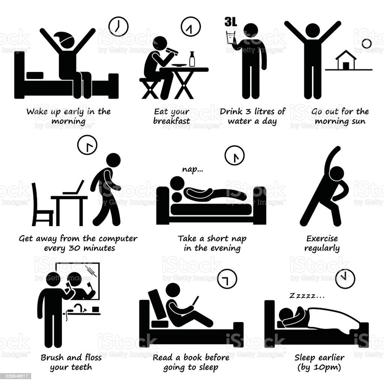What are some of the healthy habits mentioned in the image? The image effectively outlines several healthy habits critical for everyday wellness: rising early, enjoying a balanced breakfast, drinking at least 3 liters of water daily, absorbing morning sunlight, taking regular breaks from screen activity every 30 minutes, embracing brief afternoon naps, engaging in daily physical activity, maintaining oral hygiene by brushing and flossing, and concluding the day with a reading activity before an early bedtime at 10 pm. 